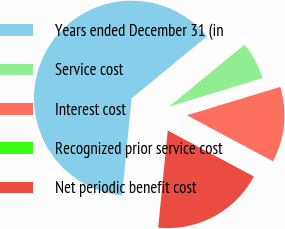Convert chart to OTSL. <chart><loc_0><loc_0><loc_500><loc_500><pie_chart><fcel>Years ended December 31 (in<fcel>Service cost<fcel>Interest cost<fcel>Recognized prior service cost<fcel>Net periodic benefit cost<nl><fcel>62.49%<fcel>6.25%<fcel>12.5%<fcel>0.0%<fcel>18.75%<nl></chart> 